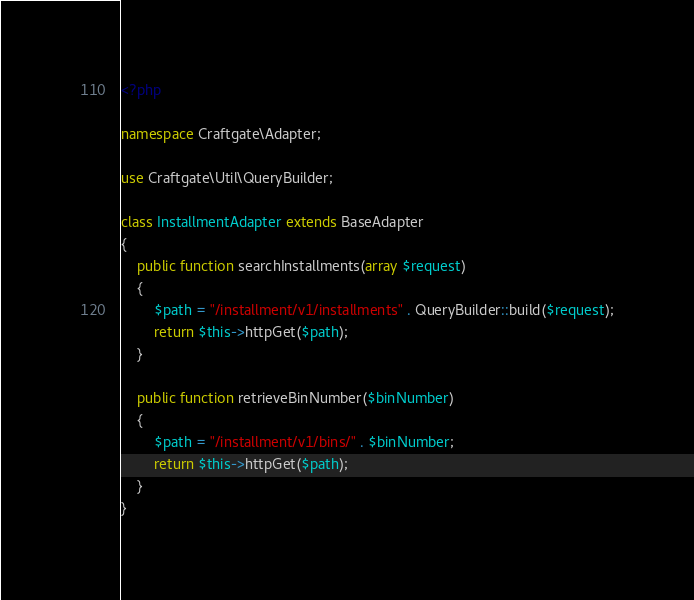<code> <loc_0><loc_0><loc_500><loc_500><_PHP_><?php

namespace Craftgate\Adapter;

use Craftgate\Util\QueryBuilder;

class InstallmentAdapter extends BaseAdapter
{
    public function searchInstallments(array $request)
    {
        $path = "/installment/v1/installments" . QueryBuilder::build($request);
        return $this->httpGet($path);
    }

    public function retrieveBinNumber($binNumber)
    {
        $path = "/installment/v1/bins/" . $binNumber;
        return $this->httpGet($path);
    }
}
</code> 